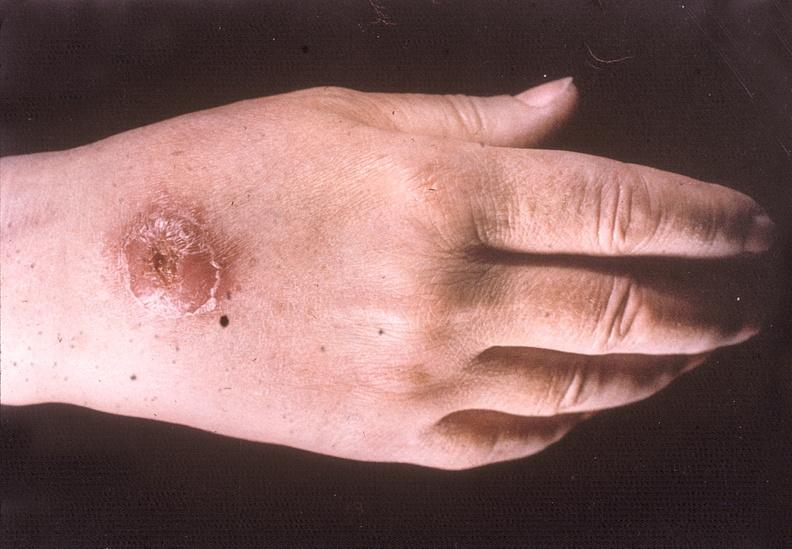does this image show hand, cutaneous leishmaniasis kala-azar?
Answer the question using a single word or phrase. Yes 